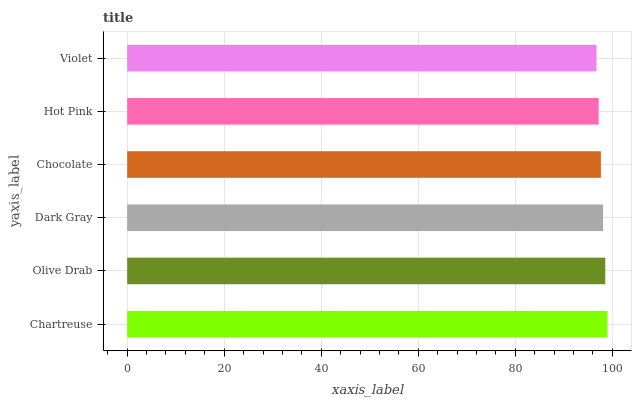Is Violet the minimum?
Answer yes or no. Yes. Is Chartreuse the maximum?
Answer yes or no. Yes. Is Olive Drab the minimum?
Answer yes or no. No. Is Olive Drab the maximum?
Answer yes or no. No. Is Chartreuse greater than Olive Drab?
Answer yes or no. Yes. Is Olive Drab less than Chartreuse?
Answer yes or no. Yes. Is Olive Drab greater than Chartreuse?
Answer yes or no. No. Is Chartreuse less than Olive Drab?
Answer yes or no. No. Is Dark Gray the high median?
Answer yes or no. Yes. Is Chocolate the low median?
Answer yes or no. Yes. Is Chartreuse the high median?
Answer yes or no. No. Is Violet the low median?
Answer yes or no. No. 